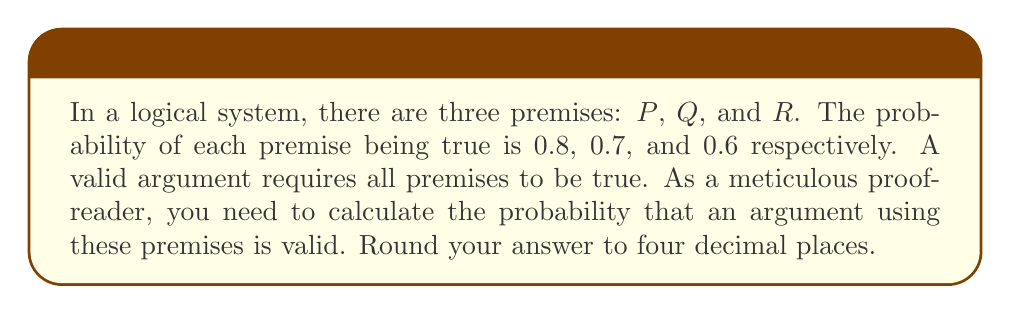Teach me how to tackle this problem. To solve this problem, we need to follow these steps:

1. Understand that for an argument to be valid, all premises must be true.
2. Recognize that the probability of all premises being true is the product of their individual probabilities, as they are independent events.
3. Calculate the probability using the given values.

Let's proceed with the calculation:

$$P(\text{valid argument}) = P(P \text{ is true}) \times P(Q \text{ is true}) \times P(R \text{ is true})$$

Substituting the given probabilities:

$$P(\text{valid argument}) = 0.8 \times 0.7 \times 0.6$$

Now, let's multiply these values:

$$P(\text{valid argument}) = 0.336$$

Rounding to four decimal places:

$$P(\text{valid argument}) \approx 0.3360$$

This means that the probability of having a valid argument given these premises is approximately 0.3360 or 33.60%.
Answer: $0.3360$ 